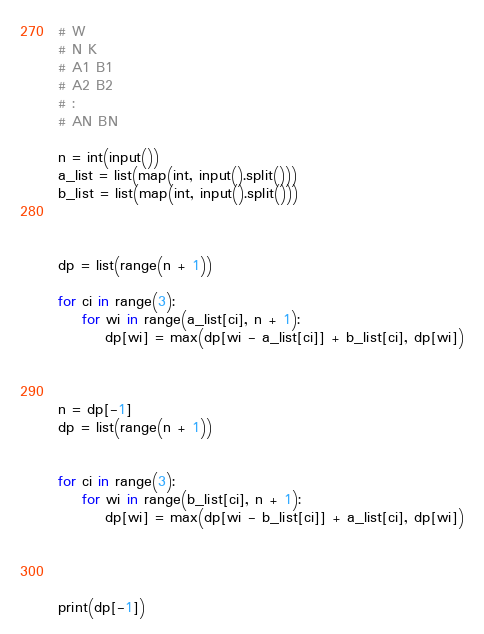<code> <loc_0><loc_0><loc_500><loc_500><_Python_># W
# N K
# A1 B1
# A2 B2
# :
# AN BN

n = int(input())
a_list = list(map(int, input().split()))
b_list = list(map(int, input().split()))



dp = list(range(n + 1))

for ci in range(3):
    for wi in range(a_list[ci], n + 1):
        dp[wi] = max(dp[wi - a_list[ci]] + b_list[ci], dp[wi])



n = dp[-1]
dp = list(range(n + 1))


for ci in range(3):
    for wi in range(b_list[ci], n + 1):
        dp[wi] = max(dp[wi - b_list[ci]] + a_list[ci], dp[wi])




print(dp[-1])</code> 